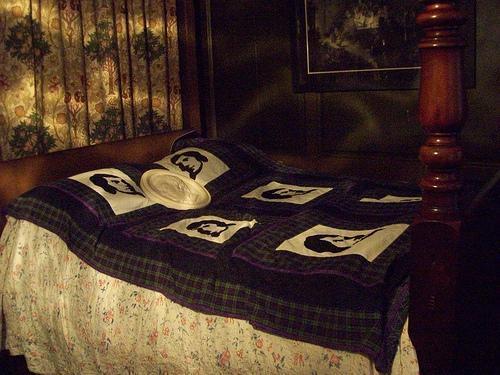How many people are in this photo?
Give a very brief answer. 0. 